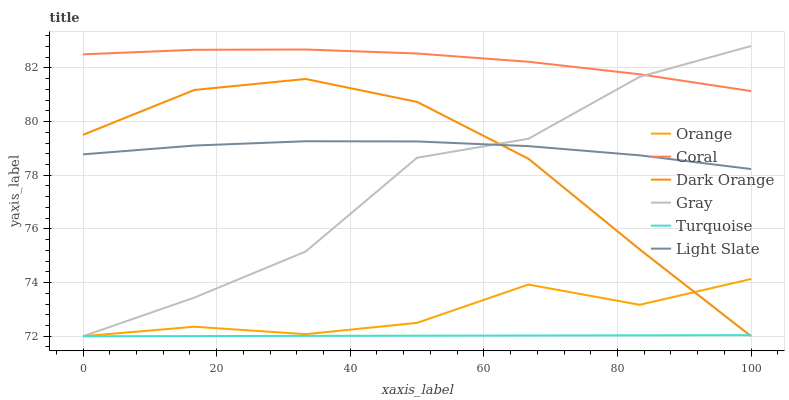Does Turquoise have the minimum area under the curve?
Answer yes or no. Yes. Does Coral have the maximum area under the curve?
Answer yes or no. Yes. Does Gray have the minimum area under the curve?
Answer yes or no. No. Does Gray have the maximum area under the curve?
Answer yes or no. No. Is Turquoise the smoothest?
Answer yes or no. Yes. Is Gray the roughest?
Answer yes or no. Yes. Is Gray the smoothest?
Answer yes or no. No. Is Turquoise the roughest?
Answer yes or no. No. Does Dark Orange have the lowest value?
Answer yes or no. Yes. Does Light Slate have the lowest value?
Answer yes or no. No. Does Gray have the highest value?
Answer yes or no. Yes. Does Turquoise have the highest value?
Answer yes or no. No. Is Light Slate less than Coral?
Answer yes or no. Yes. Is Coral greater than Orange?
Answer yes or no. Yes. Does Gray intersect Dark Orange?
Answer yes or no. Yes. Is Gray less than Dark Orange?
Answer yes or no. No. Is Gray greater than Dark Orange?
Answer yes or no. No. Does Light Slate intersect Coral?
Answer yes or no. No. 